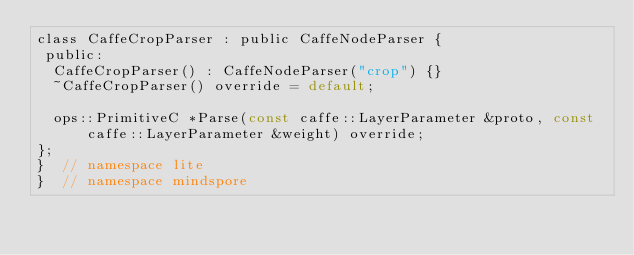Convert code to text. <code><loc_0><loc_0><loc_500><loc_500><_C_>class CaffeCropParser : public CaffeNodeParser {
 public:
  CaffeCropParser() : CaffeNodeParser("crop") {}
  ~CaffeCropParser() override = default;

  ops::PrimitiveC *Parse(const caffe::LayerParameter &proto, const caffe::LayerParameter &weight) override;
};
}  // namespace lite
}  // namespace mindspore
</code> 